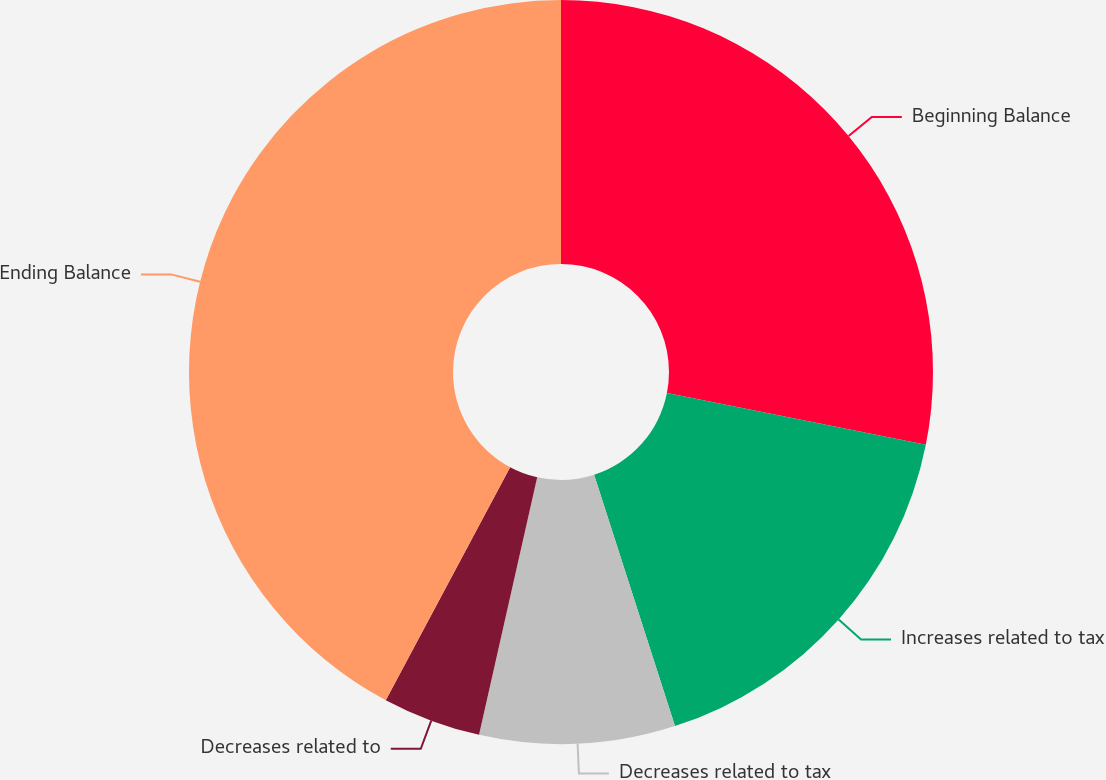Convert chart to OTSL. <chart><loc_0><loc_0><loc_500><loc_500><pie_chart><fcel>Beginning Balance<fcel>Increases related to tax<fcel>Decreases related to tax<fcel>Decreases related to<fcel>Ending Balance<nl><fcel>28.13%<fcel>16.91%<fcel>8.49%<fcel>4.27%<fcel>42.19%<nl></chart> 